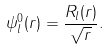<formula> <loc_0><loc_0><loc_500><loc_500>\psi _ { l } ^ { 0 } ( r ) = \frac { R _ { l } ( r ) } { \sqrt { r } } .</formula> 